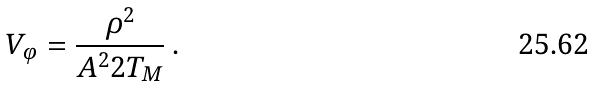Convert formula to latex. <formula><loc_0><loc_0><loc_500><loc_500>V _ { \varphi } = \frac { \rho ^ { 2 } } { A ^ { 2 } 2 T _ { M } } \, .</formula> 